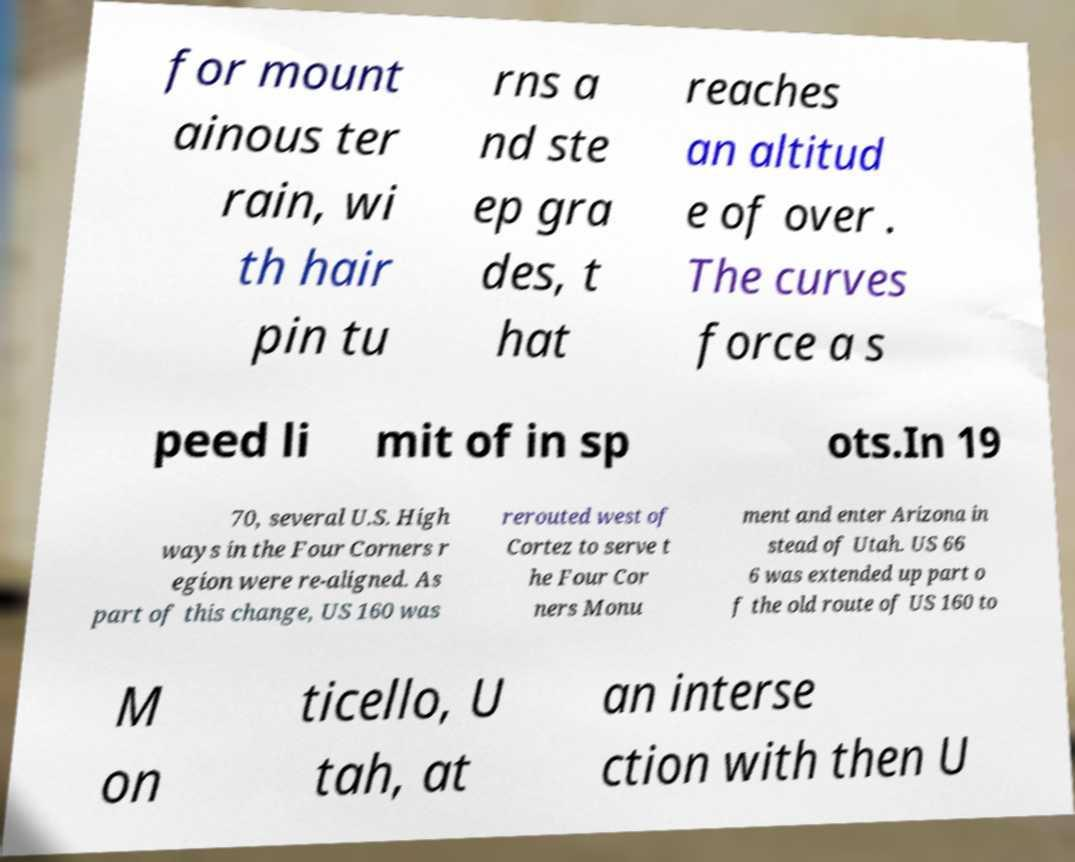What messages or text are displayed in this image? I need them in a readable, typed format. for mount ainous ter rain, wi th hair pin tu rns a nd ste ep gra des, t hat reaches an altitud e of over . The curves force a s peed li mit of in sp ots.In 19 70, several U.S. High ways in the Four Corners r egion were re-aligned. As part of this change, US 160 was rerouted west of Cortez to serve t he Four Cor ners Monu ment and enter Arizona in stead of Utah. US 66 6 was extended up part o f the old route of US 160 to M on ticello, U tah, at an interse ction with then U 